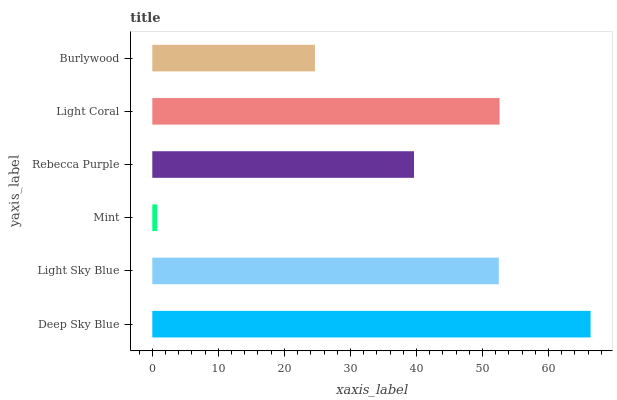Is Mint the minimum?
Answer yes or no. Yes. Is Deep Sky Blue the maximum?
Answer yes or no. Yes. Is Light Sky Blue the minimum?
Answer yes or no. No. Is Light Sky Blue the maximum?
Answer yes or no. No. Is Deep Sky Blue greater than Light Sky Blue?
Answer yes or no. Yes. Is Light Sky Blue less than Deep Sky Blue?
Answer yes or no. Yes. Is Light Sky Blue greater than Deep Sky Blue?
Answer yes or no. No. Is Deep Sky Blue less than Light Sky Blue?
Answer yes or no. No. Is Light Sky Blue the high median?
Answer yes or no. Yes. Is Rebecca Purple the low median?
Answer yes or no. Yes. Is Deep Sky Blue the high median?
Answer yes or no. No. Is Burlywood the low median?
Answer yes or no. No. 